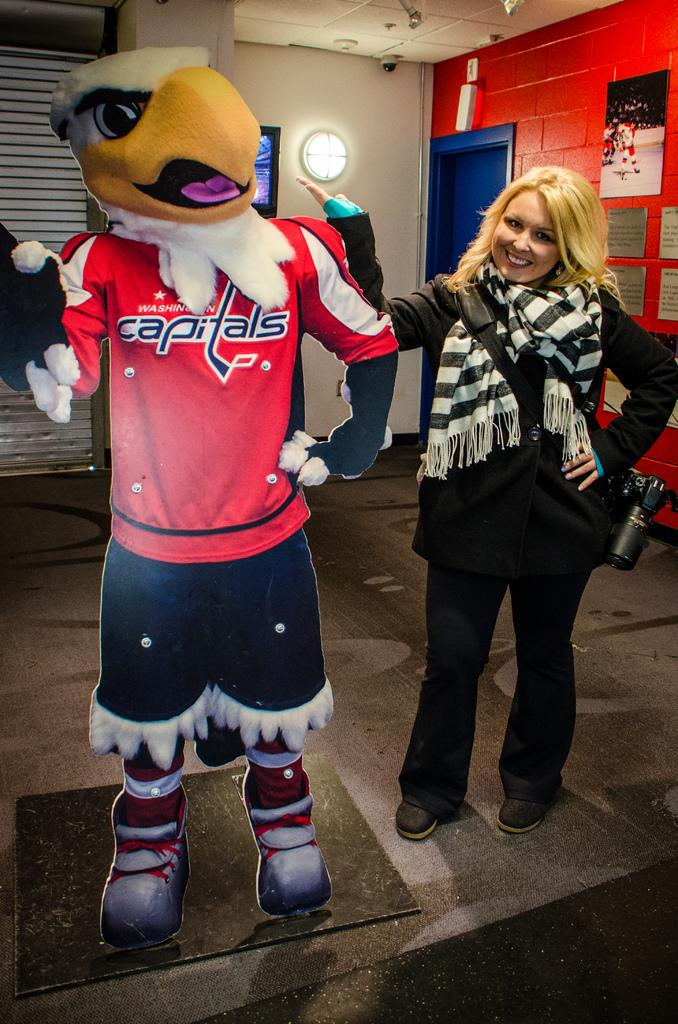<image>
Relay a brief, clear account of the picture shown. Woman posing with a Capitals eagle cardboard cut out 